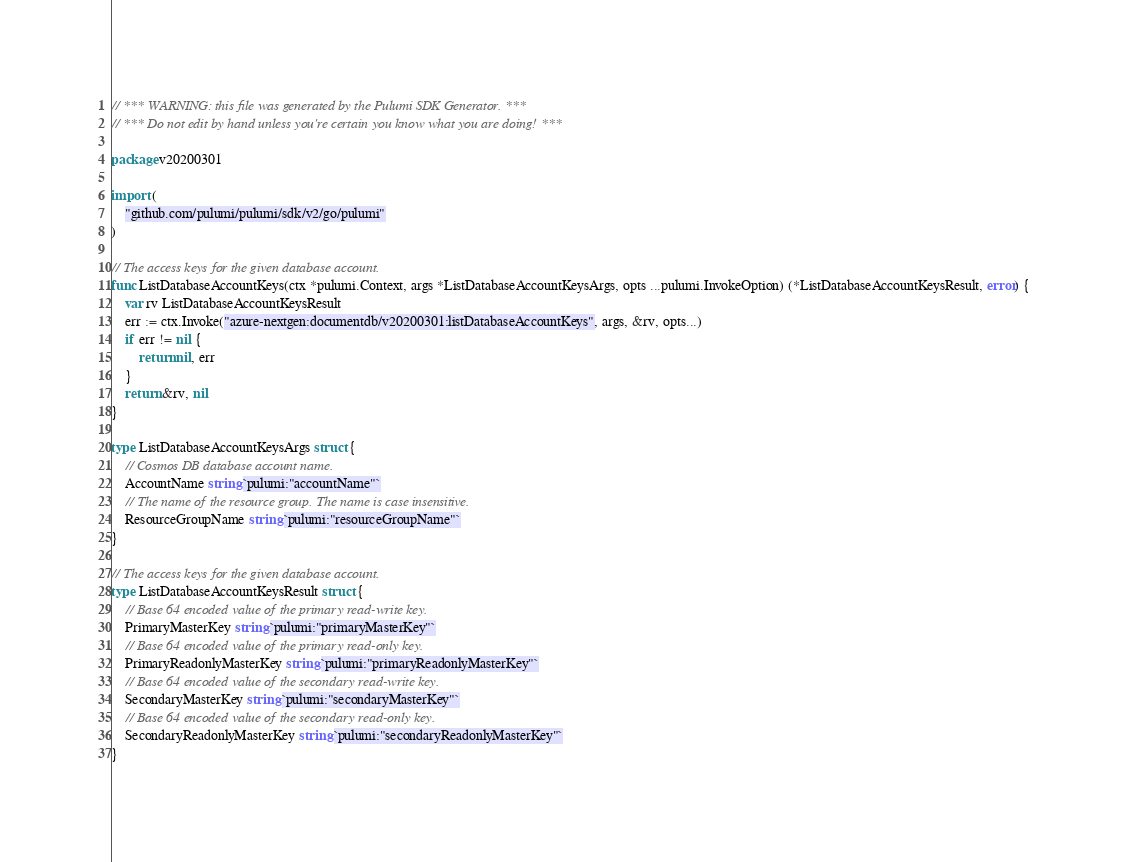<code> <loc_0><loc_0><loc_500><loc_500><_Go_>// *** WARNING: this file was generated by the Pulumi SDK Generator. ***
// *** Do not edit by hand unless you're certain you know what you are doing! ***

package v20200301

import (
	"github.com/pulumi/pulumi/sdk/v2/go/pulumi"
)

// The access keys for the given database account.
func ListDatabaseAccountKeys(ctx *pulumi.Context, args *ListDatabaseAccountKeysArgs, opts ...pulumi.InvokeOption) (*ListDatabaseAccountKeysResult, error) {
	var rv ListDatabaseAccountKeysResult
	err := ctx.Invoke("azure-nextgen:documentdb/v20200301:listDatabaseAccountKeys", args, &rv, opts...)
	if err != nil {
		return nil, err
	}
	return &rv, nil
}

type ListDatabaseAccountKeysArgs struct {
	// Cosmos DB database account name.
	AccountName string `pulumi:"accountName"`
	// The name of the resource group. The name is case insensitive.
	ResourceGroupName string `pulumi:"resourceGroupName"`
}

// The access keys for the given database account.
type ListDatabaseAccountKeysResult struct {
	// Base 64 encoded value of the primary read-write key.
	PrimaryMasterKey string `pulumi:"primaryMasterKey"`
	// Base 64 encoded value of the primary read-only key.
	PrimaryReadonlyMasterKey string `pulumi:"primaryReadonlyMasterKey"`
	// Base 64 encoded value of the secondary read-write key.
	SecondaryMasterKey string `pulumi:"secondaryMasterKey"`
	// Base 64 encoded value of the secondary read-only key.
	SecondaryReadonlyMasterKey string `pulumi:"secondaryReadonlyMasterKey"`
}
</code> 